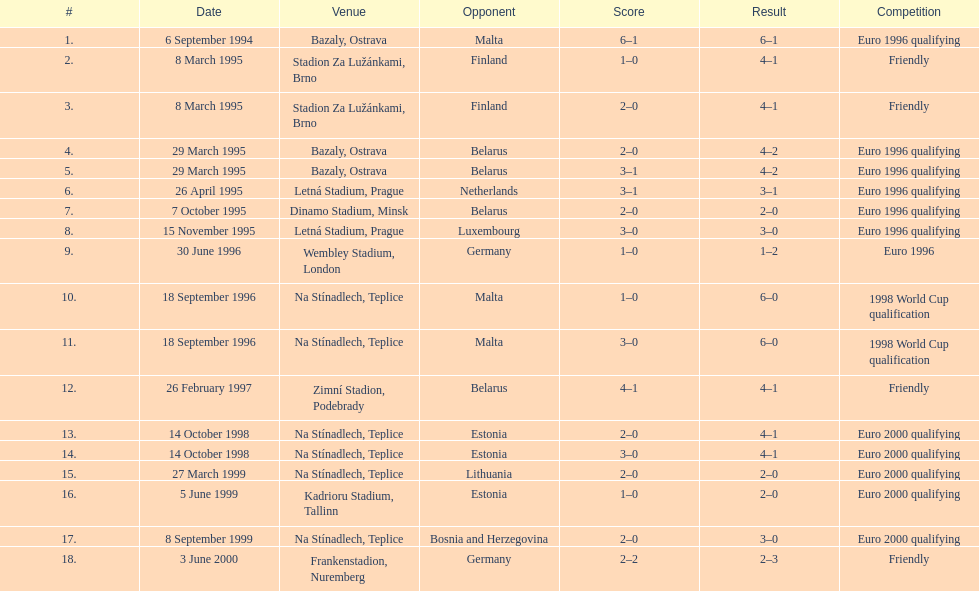What is the count of games that happened in ostrava? 2. 